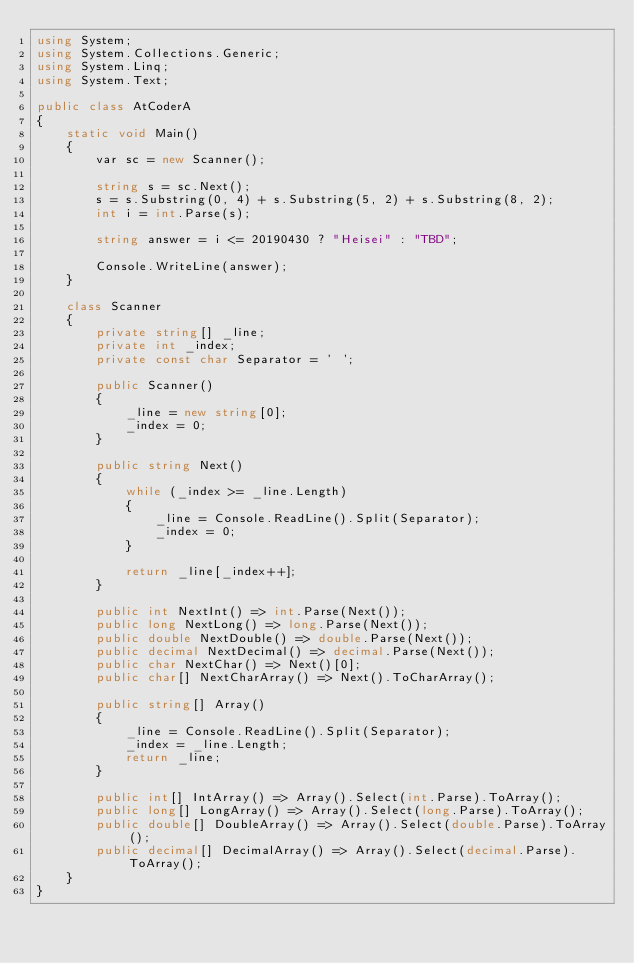<code> <loc_0><loc_0><loc_500><loc_500><_C#_>using System;
using System.Collections.Generic;
using System.Linq;
using System.Text;

public class AtCoderA
{
    static void Main()
    {
        var sc = new Scanner();

        string s = sc.Next();
        s = s.Substring(0, 4) + s.Substring(5, 2) + s.Substring(8, 2);
        int i = int.Parse(s);

        string answer = i <= 20190430 ? "Heisei" : "TBD";

        Console.WriteLine(answer);
    }

    class Scanner
    {
        private string[] _line;
        private int _index;
        private const char Separator = ' ';

        public Scanner()
        {
            _line = new string[0];
            _index = 0;
        }

        public string Next()
        {
            while (_index >= _line.Length)
            {
                _line = Console.ReadLine().Split(Separator);
                _index = 0;
            }

            return _line[_index++];
        }

        public int NextInt() => int.Parse(Next());
        public long NextLong() => long.Parse(Next());
        public double NextDouble() => double.Parse(Next());
        public decimal NextDecimal() => decimal.Parse(Next());
        public char NextChar() => Next()[0];
        public char[] NextCharArray() => Next().ToCharArray();

        public string[] Array()
        {
            _line = Console.ReadLine().Split(Separator);
            _index = _line.Length;
            return _line;
        }

        public int[] IntArray() => Array().Select(int.Parse).ToArray();
        public long[] LongArray() => Array().Select(long.Parse).ToArray();
        public double[] DoubleArray() => Array().Select(double.Parse).ToArray();
        public decimal[] DecimalArray() => Array().Select(decimal.Parse).ToArray();
    }
}</code> 